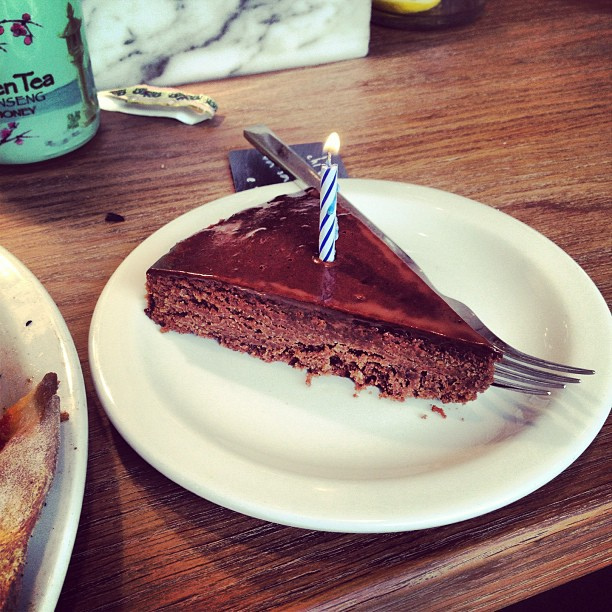<image>What berry is on the pie? There is no berry on the pie. It could be a blackberry or another kind of berry. What berry is on the pie? I don't know what berry is on the pie. It can be blackberry, blueberry or strawberry. 